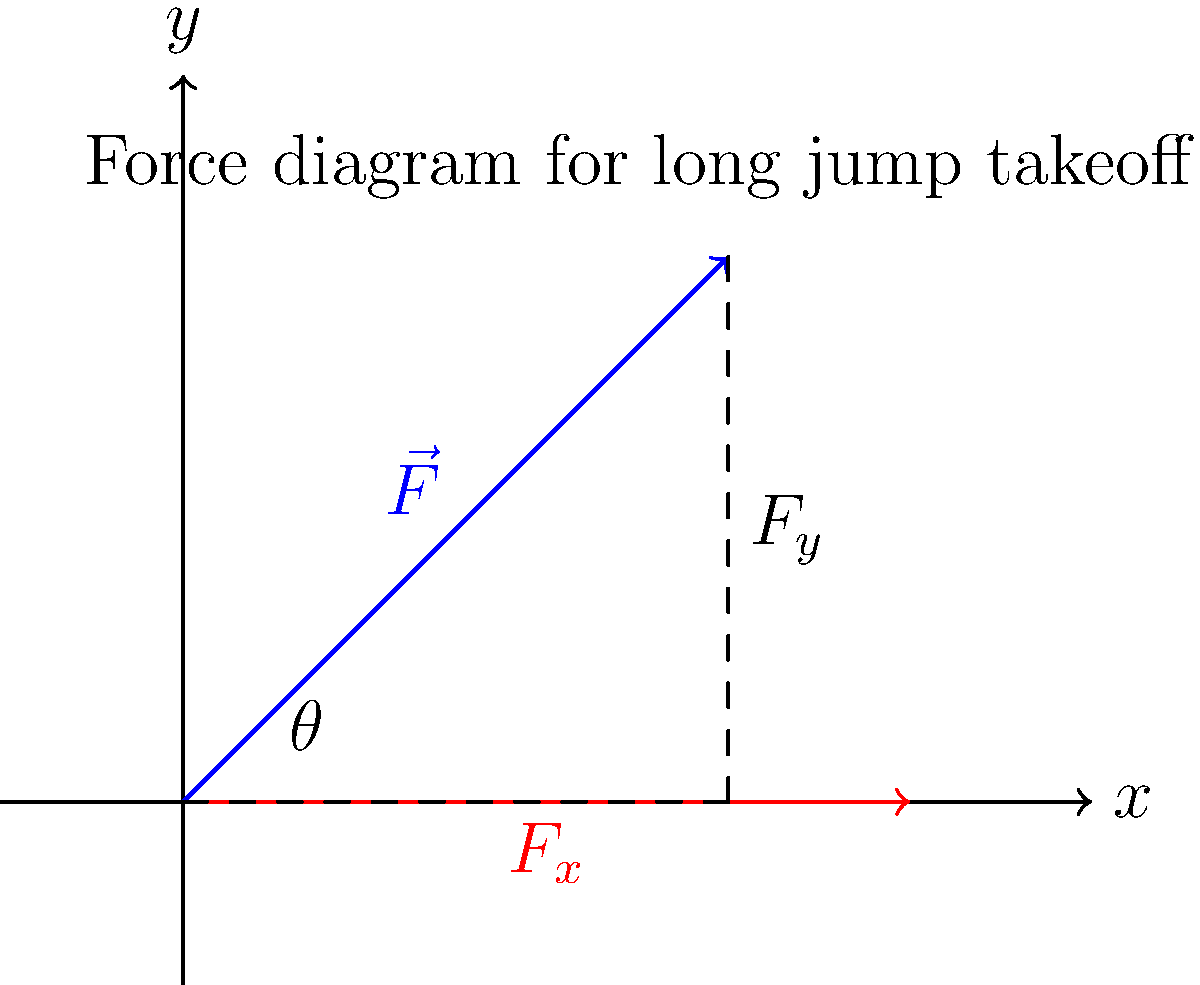As a track and field coach, you're analyzing the optimal takeoff angle for long jump. Using the force diagram provided, which shows the total force $\vec{F}$ applied by an athlete during takeoff, determine the angle $\theta$ that maximizes the horizontal distance of the jump. Assume air resistance is negligible and the athlete's initial velocity is zero. What is the optimal takeoff angle? To find the optimal takeoff angle for long jump, we need to consider the following steps:

1) The horizontal distance of a projectile (in this case, the jumper) is given by:

   $$R = \frac{v^2 \sin(2\theta)}{g}$$

   where $R$ is the range, $v$ is the initial velocity, $\theta$ is the takeoff angle, and $g$ is the acceleration due to gravity.

2) The initial velocity $v$ is determined by the force applied during takeoff. The components of this force are:

   $F_x = F \cos(\theta)$ (horizontal component)
   $F_y = F \sin(\theta)$ (vertical component)

3) To maximize the range $R$, we need to maximize $v^2 \sin(2\theta)$. 

4) The value of $v$ depends on the force applied and the time of application, which we assume to be constant for different angles. Therefore, maximizing $R$ is equivalent to maximizing $\sin(2\theta)$.

5) $\sin(2\theta)$ reaches its maximum value of 1 when $2\theta = 90°$, or when $\theta = 45°$.

6) However, in long jump, the athlete's initial height and the need to maintain forward momentum slightly reduce this angle.

7) Empirical studies and biomechanical analyses have shown that the optimal takeoff angle for long jump is typically between 21° and 24°.

Therefore, while the theoretical optimal angle for projectile motion is 45°, the practical optimal takeoff angle for long jump is lower due to the specific conditions of the event.
Answer: 21°-24° 